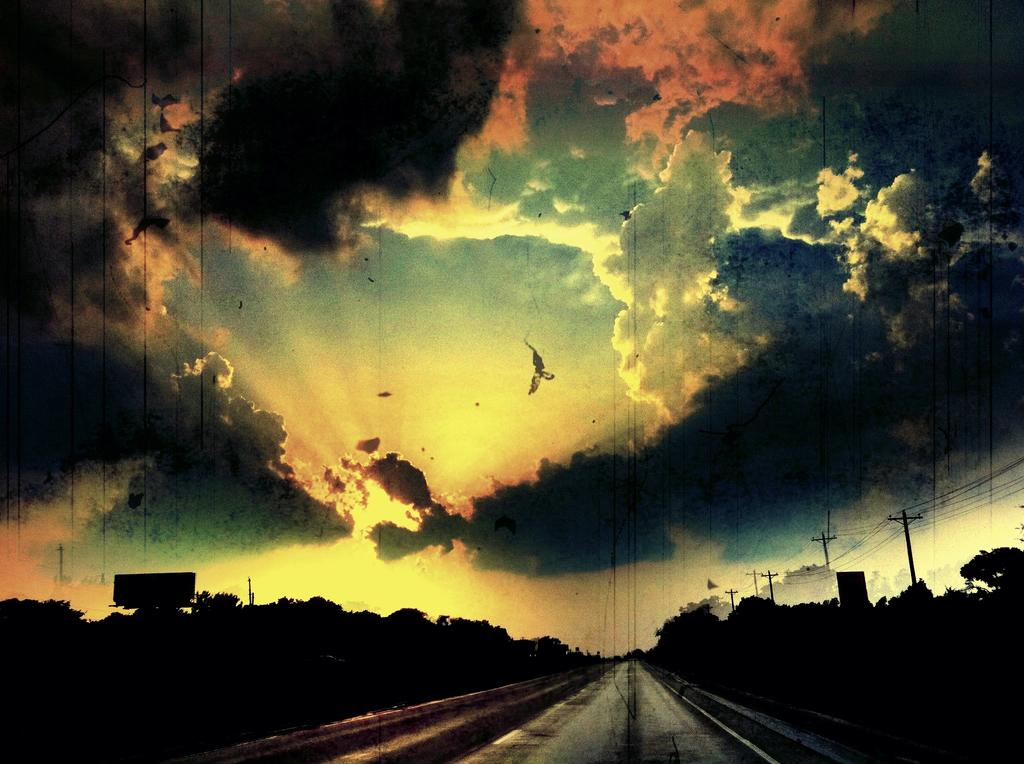What type of vegetation is at the bottom of the image? There are trees at the bottom of the image. What infrastructure elements are present at the bottom of the image? Current poles and cables are visible at the bottom of the image. What type of man-made structure is at the bottom of the image? There is a road at the bottom of the image. What other objects can be seen at the bottom of the image? Other objects are present at the bottom of the image. What is visible at the top of the image? The sky is visible at the top of the image. How many cherries are hanging from the piggyback on the trees in the image? There are no cherries or pigs present in the image; it features trees, current poles, cables, a road, and other objects at the bottom, and the sky at the top. 